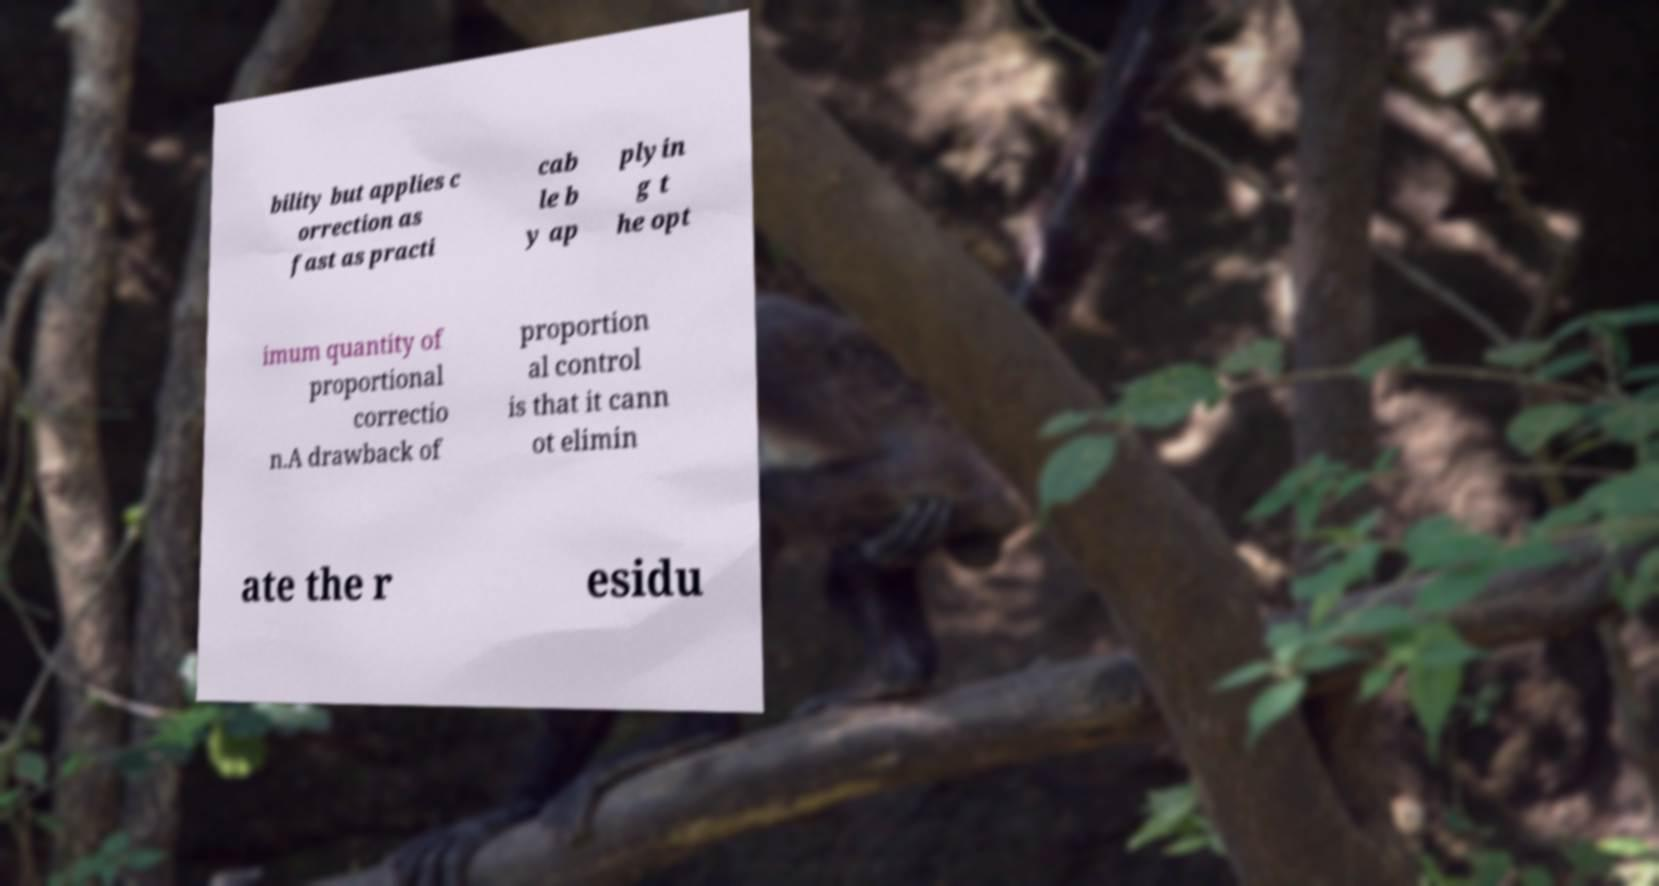Could you extract and type out the text from this image? bility but applies c orrection as fast as practi cab le b y ap plyin g t he opt imum quantity of proportional correctio n.A drawback of proportion al control is that it cann ot elimin ate the r esidu 